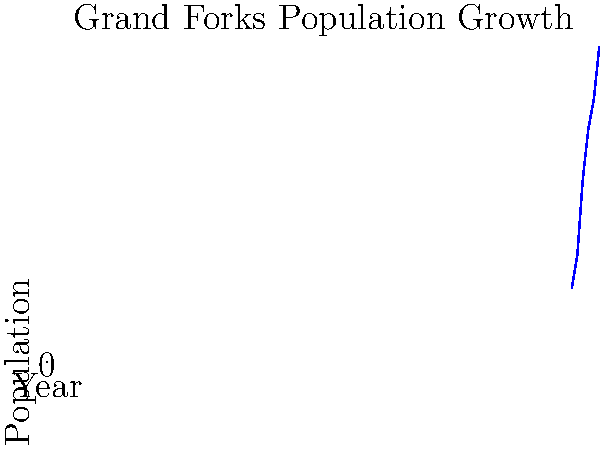Based on the line graph showing Grand Forks' population growth from 1920 to 2020, in which 20-year period did the city experience its most significant population increase? To determine the period with the most significant population growth, we need to calculate and compare the population increases for each 20-year period:

1. 1920-1940: 20,228 - 14,010 = 6,218
2. 1940-1960: 34,451 - 20,228 = 14,223
3. 1960-1980: 43,765 - 34,451 = 9,314
4. 1980-2000: 49,321 - 43,765 = 5,556
5. 2000-2020: 59,166 - 49,321 = 9,845

The largest increase occurred between 1940 and 1960, with a population growth of 14,223 people.
Answer: 1940-1960 